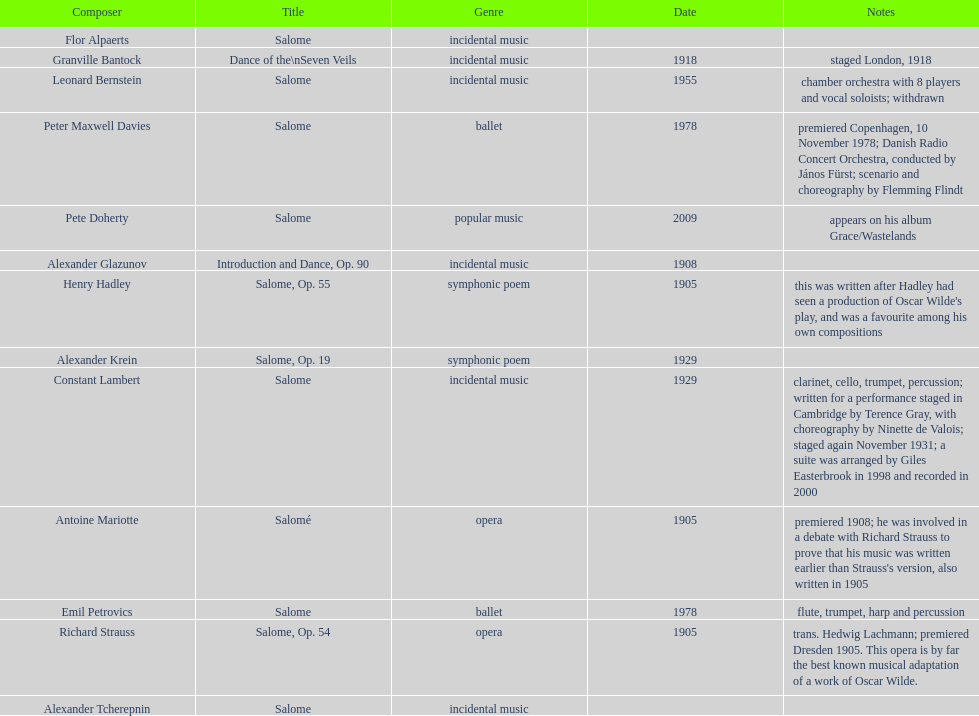What work was written after henry hadley had seen an oscar wilde play? Salome, Op. 55. 